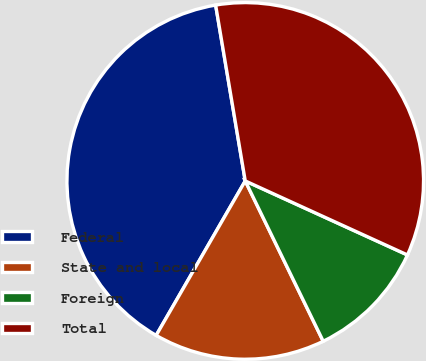Convert chart. <chart><loc_0><loc_0><loc_500><loc_500><pie_chart><fcel>Federal<fcel>State and local<fcel>Foreign<fcel>Total<nl><fcel>39.02%<fcel>15.53%<fcel>10.98%<fcel>34.47%<nl></chart> 